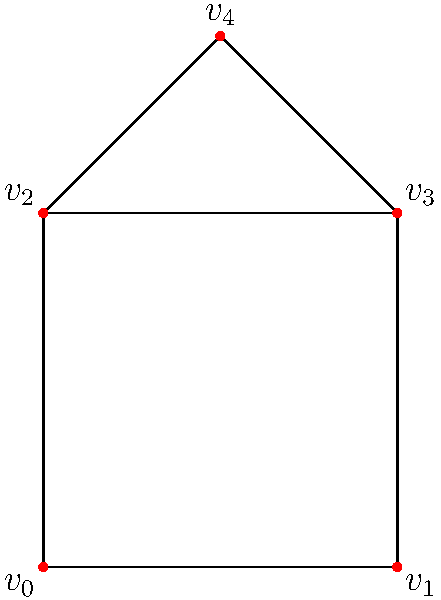Consider a simplicial complex representing the structure of a Lua-based neural network, as shown in the figure. Determine the rank of the first homology group $H_1$ of this complex. To find the rank of the first homology group $H_1$, we need to follow these steps:

1. Identify the simplices:
   0-simplices (vertices): $\{v_0, v_1, v_2, v_3, v_4\}$
   1-simplices (edges): $\{[v_0v_1], [v_1v_3], [v_3v_2], [v_2v_0], [v_2v_4], [v_4v_3]\}$
   2-simplices (triangles): $\{[v_0v_1v_3], [v_0v_3v_2], [v_2v_3v_4]\}$

2. Calculate the number of simplices:
   $n_0 = 5$ (vertices)
   $n_1 = 6$ (edges)
   $n_2 = 3$ (triangles)

3. Compute the Euler characteristic:
   $\chi = n_0 - n_1 + n_2 = 5 - 6 + 3 = 2$

4. The Euler characteristic is related to the Betti numbers by:
   $\chi = \beta_0 - \beta_1 + \beta_2$

5. We know that $\beta_0 = 1$ (connected component) and $\beta_2 = 0$ (no voids):
   $2 = 1 - \beta_1 + 0$

6. Solve for $\beta_1$:
   $\beta_1 = 1 - 2 = -1$

7. The rank of $H_1$ is equal to $\beta_1$, but it cannot be negative. Therefore, $\beta_1 = 0$.

Thus, the rank of the first homology group $H_1$ is 0.
Answer: 0 